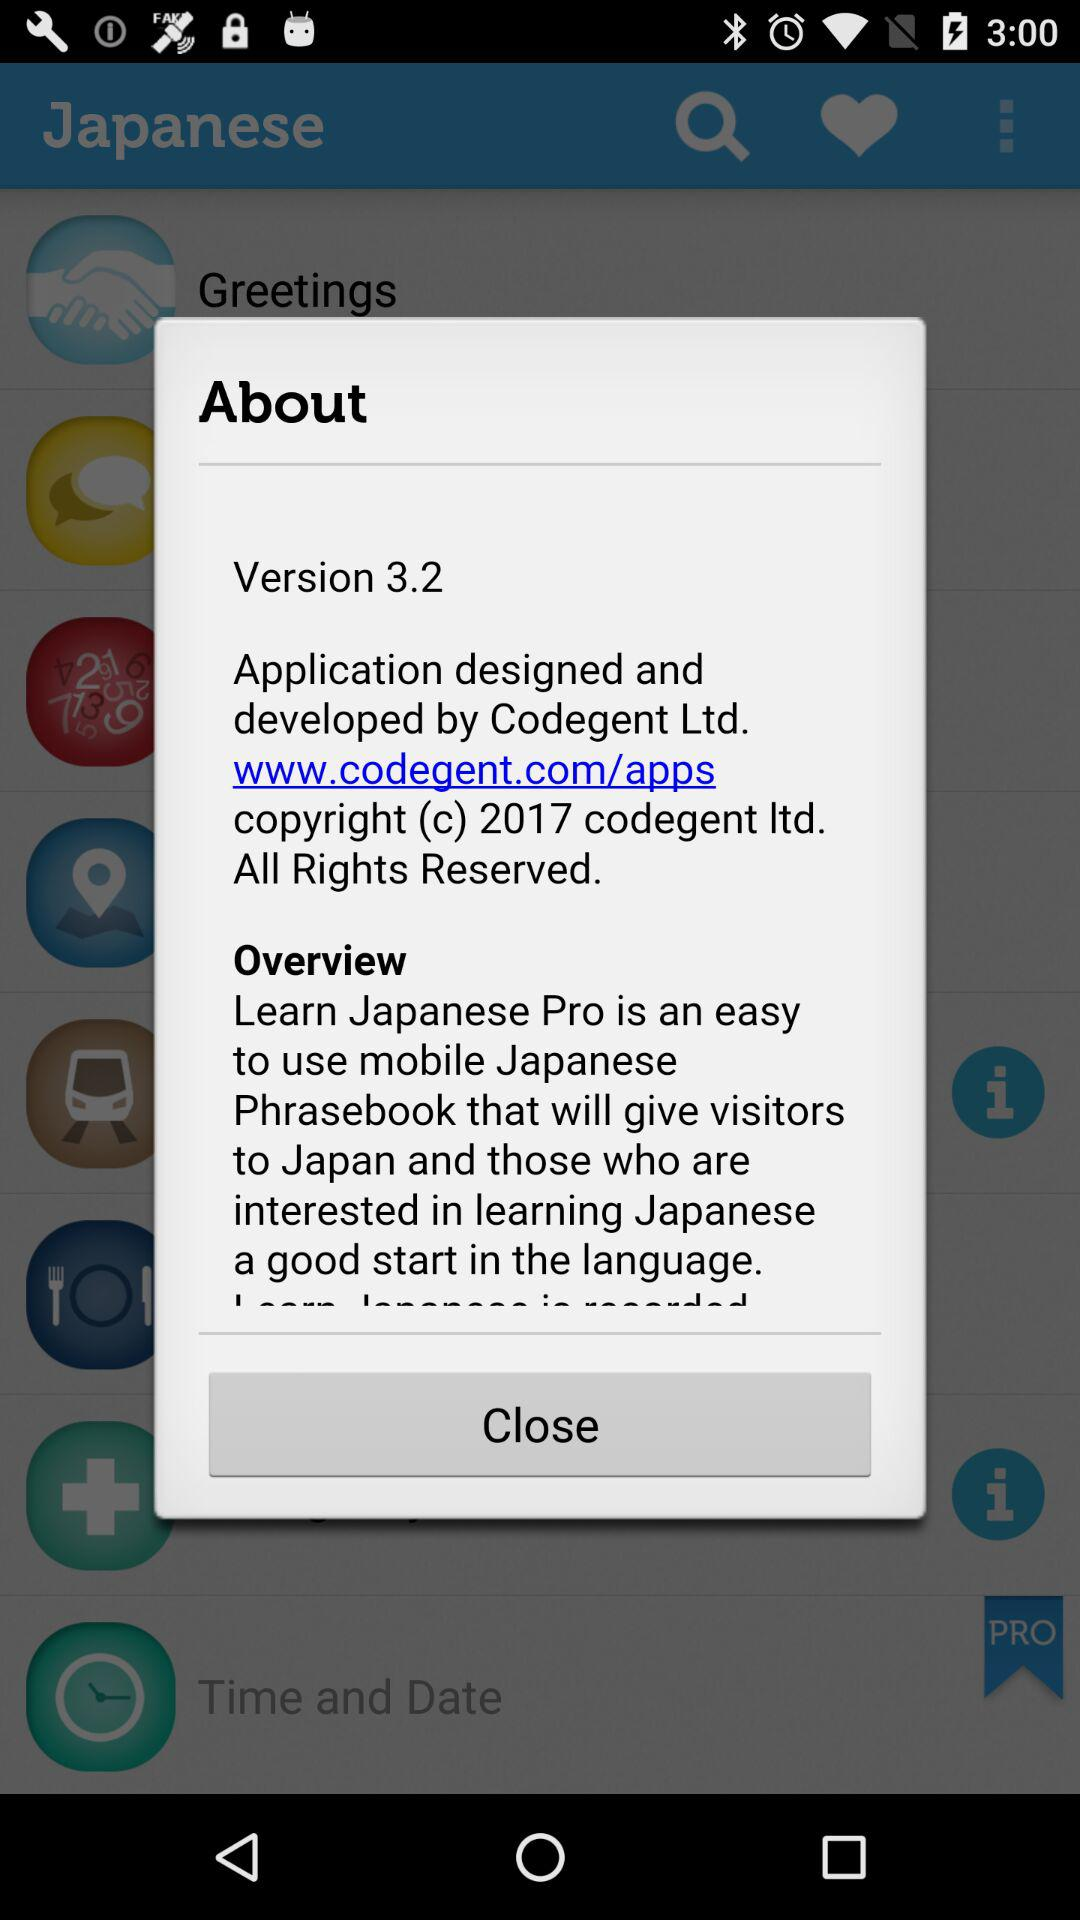What company designed and developed the application? The application is designed and developed by Codegent Ltd. 